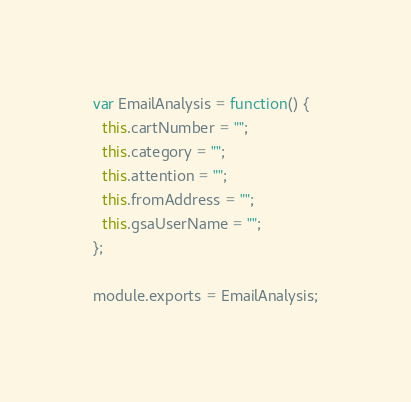<code> <loc_0><loc_0><loc_500><loc_500><_JavaScript_>var EmailAnalysis = function() {
  this.cartNumber = "";
  this.category = "";
  this.attention = "";
  this.fromAddress = "";
  this.gsaUserName = "";
};

module.exports = EmailAnalysis;
</code> 